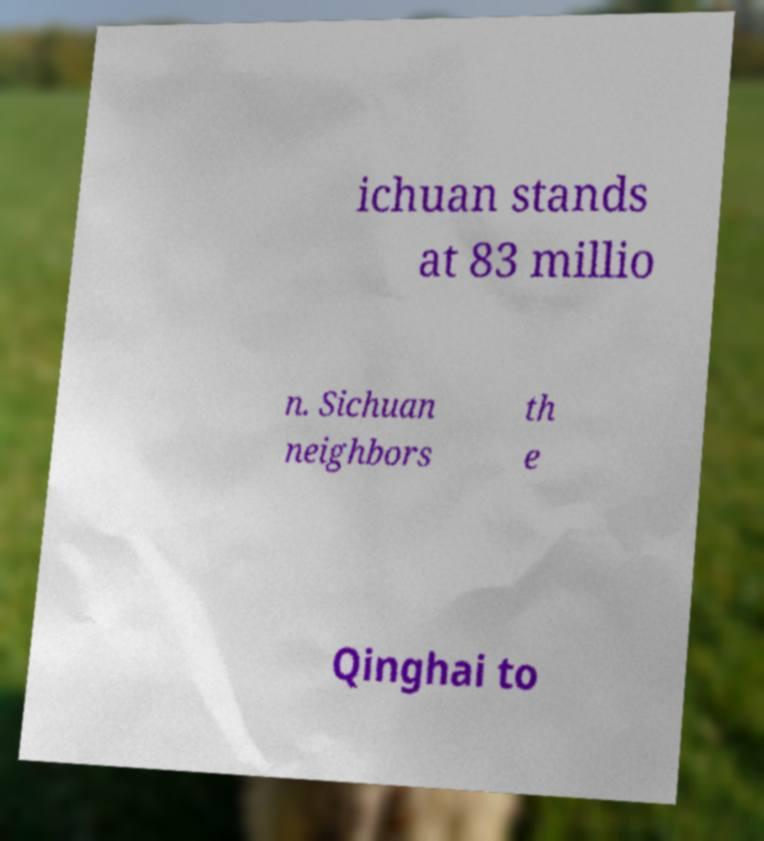Could you extract and type out the text from this image? ichuan stands at 83 millio n. Sichuan neighbors th e Qinghai to 